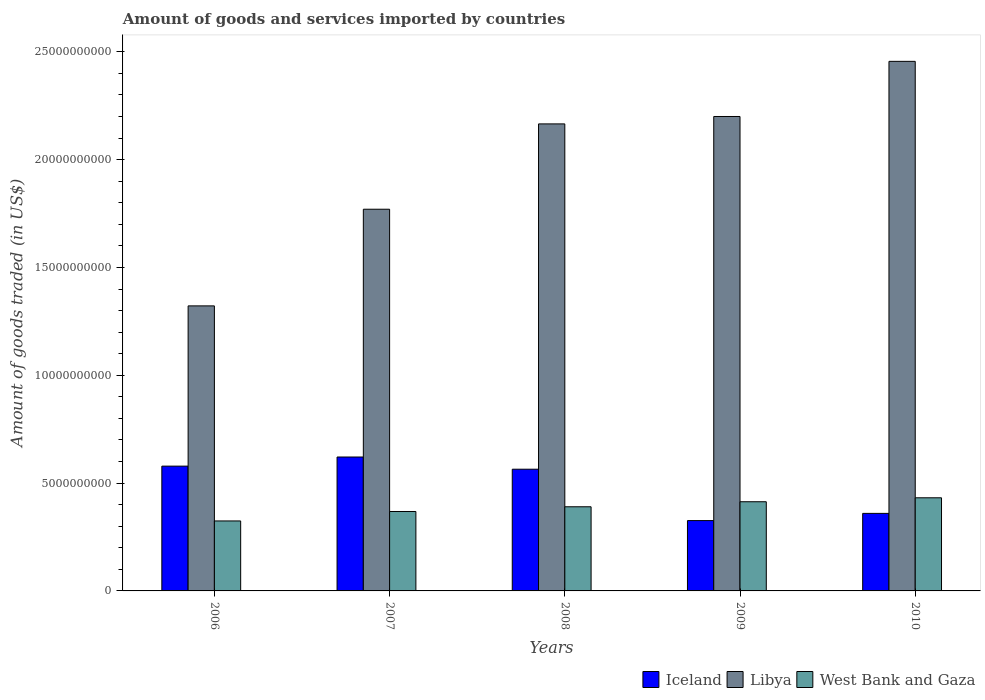How many groups of bars are there?
Offer a terse response. 5. What is the total amount of goods and services imported in Libya in 2006?
Give a very brief answer. 1.32e+1. Across all years, what is the maximum total amount of goods and services imported in Iceland?
Provide a succinct answer. 6.21e+09. Across all years, what is the minimum total amount of goods and services imported in Libya?
Your answer should be compact. 1.32e+1. What is the total total amount of goods and services imported in Libya in the graph?
Offer a very short reply. 9.91e+1. What is the difference between the total amount of goods and services imported in Libya in 2006 and that in 2009?
Ensure brevity in your answer.  -8.78e+09. What is the difference between the total amount of goods and services imported in Iceland in 2007 and the total amount of goods and services imported in Libya in 2006?
Provide a short and direct response. -7.01e+09. What is the average total amount of goods and services imported in West Bank and Gaza per year?
Ensure brevity in your answer.  3.86e+09. In the year 2010, what is the difference between the total amount of goods and services imported in Libya and total amount of goods and services imported in West Bank and Gaza?
Ensure brevity in your answer.  2.02e+1. In how many years, is the total amount of goods and services imported in Iceland greater than 10000000000 US$?
Your answer should be very brief. 0. What is the ratio of the total amount of goods and services imported in West Bank and Gaza in 2006 to that in 2008?
Provide a short and direct response. 0.83. What is the difference between the highest and the second highest total amount of goods and services imported in Libya?
Give a very brief answer. 2.56e+09. What is the difference between the highest and the lowest total amount of goods and services imported in West Bank and Gaza?
Provide a succinct answer. 1.07e+09. What does the 2nd bar from the left in 2006 represents?
Make the answer very short. Libya. What does the 1st bar from the right in 2006 represents?
Provide a succinct answer. West Bank and Gaza. Is it the case that in every year, the sum of the total amount of goods and services imported in Iceland and total amount of goods and services imported in West Bank and Gaza is greater than the total amount of goods and services imported in Libya?
Provide a succinct answer. No. How many bars are there?
Offer a very short reply. 15. Are all the bars in the graph horizontal?
Keep it short and to the point. No. How many years are there in the graph?
Provide a succinct answer. 5. What is the difference between two consecutive major ticks on the Y-axis?
Offer a very short reply. 5.00e+09. Where does the legend appear in the graph?
Your response must be concise. Bottom right. How many legend labels are there?
Your answer should be compact. 3. How are the legend labels stacked?
Provide a short and direct response. Horizontal. What is the title of the graph?
Your response must be concise. Amount of goods and services imported by countries. Does "Lithuania" appear as one of the legend labels in the graph?
Your response must be concise. No. What is the label or title of the Y-axis?
Ensure brevity in your answer.  Amount of goods traded (in US$). What is the Amount of goods traded (in US$) of Iceland in 2006?
Keep it short and to the point. 5.79e+09. What is the Amount of goods traded (in US$) in Libya in 2006?
Give a very brief answer. 1.32e+1. What is the Amount of goods traded (in US$) of West Bank and Gaza in 2006?
Provide a short and direct response. 3.25e+09. What is the Amount of goods traded (in US$) of Iceland in 2007?
Provide a short and direct response. 6.21e+09. What is the Amount of goods traded (in US$) of Libya in 2007?
Provide a succinct answer. 1.77e+1. What is the Amount of goods traded (in US$) in West Bank and Gaza in 2007?
Offer a very short reply. 3.68e+09. What is the Amount of goods traded (in US$) in Iceland in 2008?
Your answer should be compact. 5.64e+09. What is the Amount of goods traded (in US$) in Libya in 2008?
Provide a succinct answer. 2.17e+1. What is the Amount of goods traded (in US$) in West Bank and Gaza in 2008?
Keep it short and to the point. 3.90e+09. What is the Amount of goods traded (in US$) of Iceland in 2009?
Offer a terse response. 3.26e+09. What is the Amount of goods traded (in US$) of Libya in 2009?
Keep it short and to the point. 2.20e+1. What is the Amount of goods traded (in US$) in West Bank and Gaza in 2009?
Your response must be concise. 4.14e+09. What is the Amount of goods traded (in US$) in Iceland in 2010?
Make the answer very short. 3.60e+09. What is the Amount of goods traded (in US$) in Libya in 2010?
Ensure brevity in your answer.  2.46e+1. What is the Amount of goods traded (in US$) of West Bank and Gaza in 2010?
Offer a very short reply. 4.32e+09. Across all years, what is the maximum Amount of goods traded (in US$) in Iceland?
Keep it short and to the point. 6.21e+09. Across all years, what is the maximum Amount of goods traded (in US$) of Libya?
Make the answer very short. 2.46e+1. Across all years, what is the maximum Amount of goods traded (in US$) in West Bank and Gaza?
Keep it short and to the point. 4.32e+09. Across all years, what is the minimum Amount of goods traded (in US$) of Iceland?
Give a very brief answer. 3.26e+09. Across all years, what is the minimum Amount of goods traded (in US$) in Libya?
Offer a very short reply. 1.32e+1. Across all years, what is the minimum Amount of goods traded (in US$) of West Bank and Gaza?
Your response must be concise. 3.25e+09. What is the total Amount of goods traded (in US$) in Iceland in the graph?
Provide a succinct answer. 2.45e+1. What is the total Amount of goods traded (in US$) in Libya in the graph?
Keep it short and to the point. 9.91e+1. What is the total Amount of goods traded (in US$) of West Bank and Gaza in the graph?
Your answer should be compact. 1.93e+1. What is the difference between the Amount of goods traded (in US$) in Iceland in 2006 and that in 2007?
Ensure brevity in your answer.  -4.23e+08. What is the difference between the Amount of goods traded (in US$) of Libya in 2006 and that in 2007?
Ensure brevity in your answer.  -4.48e+09. What is the difference between the Amount of goods traded (in US$) in West Bank and Gaza in 2006 and that in 2007?
Offer a very short reply. -4.38e+08. What is the difference between the Amount of goods traded (in US$) in Iceland in 2006 and that in 2008?
Offer a terse response. 1.43e+08. What is the difference between the Amount of goods traded (in US$) of Libya in 2006 and that in 2008?
Give a very brief answer. -8.44e+09. What is the difference between the Amount of goods traded (in US$) of West Bank and Gaza in 2006 and that in 2008?
Provide a short and direct response. -6.58e+08. What is the difference between the Amount of goods traded (in US$) in Iceland in 2006 and that in 2009?
Provide a short and direct response. 2.53e+09. What is the difference between the Amount of goods traded (in US$) in Libya in 2006 and that in 2009?
Your answer should be compact. -8.78e+09. What is the difference between the Amount of goods traded (in US$) of West Bank and Gaza in 2006 and that in 2009?
Give a very brief answer. -8.91e+08. What is the difference between the Amount of goods traded (in US$) of Iceland in 2006 and that in 2010?
Ensure brevity in your answer.  2.19e+09. What is the difference between the Amount of goods traded (in US$) in Libya in 2006 and that in 2010?
Provide a succinct answer. -1.13e+1. What is the difference between the Amount of goods traded (in US$) in West Bank and Gaza in 2006 and that in 2010?
Your answer should be very brief. -1.07e+09. What is the difference between the Amount of goods traded (in US$) of Iceland in 2007 and that in 2008?
Ensure brevity in your answer.  5.66e+08. What is the difference between the Amount of goods traded (in US$) of Libya in 2007 and that in 2008?
Make the answer very short. -3.96e+09. What is the difference between the Amount of goods traded (in US$) in West Bank and Gaza in 2007 and that in 2008?
Provide a short and direct response. -2.19e+08. What is the difference between the Amount of goods traded (in US$) of Iceland in 2007 and that in 2009?
Provide a short and direct response. 2.95e+09. What is the difference between the Amount of goods traded (in US$) in Libya in 2007 and that in 2009?
Your response must be concise. -4.30e+09. What is the difference between the Amount of goods traded (in US$) in West Bank and Gaza in 2007 and that in 2009?
Give a very brief answer. -4.52e+08. What is the difference between the Amount of goods traded (in US$) in Iceland in 2007 and that in 2010?
Your answer should be compact. 2.61e+09. What is the difference between the Amount of goods traded (in US$) in Libya in 2007 and that in 2010?
Your response must be concise. -6.86e+09. What is the difference between the Amount of goods traded (in US$) in West Bank and Gaza in 2007 and that in 2010?
Your answer should be very brief. -6.35e+08. What is the difference between the Amount of goods traded (in US$) in Iceland in 2008 and that in 2009?
Give a very brief answer. 2.38e+09. What is the difference between the Amount of goods traded (in US$) of Libya in 2008 and that in 2009?
Offer a terse response. -3.44e+08. What is the difference between the Amount of goods traded (in US$) of West Bank and Gaza in 2008 and that in 2009?
Your answer should be very brief. -2.33e+08. What is the difference between the Amount of goods traded (in US$) in Iceland in 2008 and that in 2010?
Give a very brief answer. 2.05e+09. What is the difference between the Amount of goods traded (in US$) of Libya in 2008 and that in 2010?
Offer a very short reply. -2.90e+09. What is the difference between the Amount of goods traded (in US$) of West Bank and Gaza in 2008 and that in 2010?
Your response must be concise. -4.16e+08. What is the difference between the Amount of goods traded (in US$) in Iceland in 2009 and that in 2010?
Keep it short and to the point. -3.34e+08. What is the difference between the Amount of goods traded (in US$) in Libya in 2009 and that in 2010?
Provide a short and direct response. -2.56e+09. What is the difference between the Amount of goods traded (in US$) in West Bank and Gaza in 2009 and that in 2010?
Keep it short and to the point. -1.83e+08. What is the difference between the Amount of goods traded (in US$) in Iceland in 2006 and the Amount of goods traded (in US$) in Libya in 2007?
Give a very brief answer. -1.19e+1. What is the difference between the Amount of goods traded (in US$) of Iceland in 2006 and the Amount of goods traded (in US$) of West Bank and Gaza in 2007?
Make the answer very short. 2.10e+09. What is the difference between the Amount of goods traded (in US$) in Libya in 2006 and the Amount of goods traded (in US$) in West Bank and Gaza in 2007?
Offer a very short reply. 9.54e+09. What is the difference between the Amount of goods traded (in US$) in Iceland in 2006 and the Amount of goods traded (in US$) in Libya in 2008?
Offer a very short reply. -1.59e+1. What is the difference between the Amount of goods traded (in US$) of Iceland in 2006 and the Amount of goods traded (in US$) of West Bank and Gaza in 2008?
Make the answer very short. 1.88e+09. What is the difference between the Amount of goods traded (in US$) in Libya in 2006 and the Amount of goods traded (in US$) in West Bank and Gaza in 2008?
Ensure brevity in your answer.  9.32e+09. What is the difference between the Amount of goods traded (in US$) of Iceland in 2006 and the Amount of goods traded (in US$) of Libya in 2009?
Your response must be concise. -1.62e+1. What is the difference between the Amount of goods traded (in US$) of Iceland in 2006 and the Amount of goods traded (in US$) of West Bank and Gaza in 2009?
Your answer should be compact. 1.65e+09. What is the difference between the Amount of goods traded (in US$) of Libya in 2006 and the Amount of goods traded (in US$) of West Bank and Gaza in 2009?
Provide a short and direct response. 9.08e+09. What is the difference between the Amount of goods traded (in US$) in Iceland in 2006 and the Amount of goods traded (in US$) in Libya in 2010?
Offer a very short reply. -1.88e+1. What is the difference between the Amount of goods traded (in US$) of Iceland in 2006 and the Amount of goods traded (in US$) of West Bank and Gaza in 2010?
Give a very brief answer. 1.47e+09. What is the difference between the Amount of goods traded (in US$) in Libya in 2006 and the Amount of goods traded (in US$) in West Bank and Gaza in 2010?
Your answer should be compact. 8.90e+09. What is the difference between the Amount of goods traded (in US$) of Iceland in 2007 and the Amount of goods traded (in US$) of Libya in 2008?
Make the answer very short. -1.54e+1. What is the difference between the Amount of goods traded (in US$) in Iceland in 2007 and the Amount of goods traded (in US$) in West Bank and Gaza in 2008?
Give a very brief answer. 2.31e+09. What is the difference between the Amount of goods traded (in US$) in Libya in 2007 and the Amount of goods traded (in US$) in West Bank and Gaza in 2008?
Offer a terse response. 1.38e+1. What is the difference between the Amount of goods traded (in US$) of Iceland in 2007 and the Amount of goods traded (in US$) of Libya in 2009?
Provide a short and direct response. -1.58e+1. What is the difference between the Amount of goods traded (in US$) of Iceland in 2007 and the Amount of goods traded (in US$) of West Bank and Gaza in 2009?
Your answer should be very brief. 2.07e+09. What is the difference between the Amount of goods traded (in US$) of Libya in 2007 and the Amount of goods traded (in US$) of West Bank and Gaza in 2009?
Provide a succinct answer. 1.36e+1. What is the difference between the Amount of goods traded (in US$) in Iceland in 2007 and the Amount of goods traded (in US$) in Libya in 2010?
Offer a very short reply. -1.83e+1. What is the difference between the Amount of goods traded (in US$) of Iceland in 2007 and the Amount of goods traded (in US$) of West Bank and Gaza in 2010?
Keep it short and to the point. 1.89e+09. What is the difference between the Amount of goods traded (in US$) of Libya in 2007 and the Amount of goods traded (in US$) of West Bank and Gaza in 2010?
Your response must be concise. 1.34e+1. What is the difference between the Amount of goods traded (in US$) in Iceland in 2008 and the Amount of goods traded (in US$) in Libya in 2009?
Provide a succinct answer. -1.64e+1. What is the difference between the Amount of goods traded (in US$) of Iceland in 2008 and the Amount of goods traded (in US$) of West Bank and Gaza in 2009?
Give a very brief answer. 1.51e+09. What is the difference between the Amount of goods traded (in US$) of Libya in 2008 and the Amount of goods traded (in US$) of West Bank and Gaza in 2009?
Keep it short and to the point. 1.75e+1. What is the difference between the Amount of goods traded (in US$) of Iceland in 2008 and the Amount of goods traded (in US$) of Libya in 2010?
Provide a succinct answer. -1.89e+1. What is the difference between the Amount of goods traded (in US$) in Iceland in 2008 and the Amount of goods traded (in US$) in West Bank and Gaza in 2010?
Your response must be concise. 1.33e+09. What is the difference between the Amount of goods traded (in US$) in Libya in 2008 and the Amount of goods traded (in US$) in West Bank and Gaza in 2010?
Make the answer very short. 1.73e+1. What is the difference between the Amount of goods traded (in US$) of Iceland in 2009 and the Amount of goods traded (in US$) of Libya in 2010?
Give a very brief answer. -2.13e+1. What is the difference between the Amount of goods traded (in US$) in Iceland in 2009 and the Amount of goods traded (in US$) in West Bank and Gaza in 2010?
Provide a succinct answer. -1.06e+09. What is the difference between the Amount of goods traded (in US$) of Libya in 2009 and the Amount of goods traded (in US$) of West Bank and Gaza in 2010?
Keep it short and to the point. 1.77e+1. What is the average Amount of goods traded (in US$) in Iceland per year?
Give a very brief answer. 4.90e+09. What is the average Amount of goods traded (in US$) of Libya per year?
Your response must be concise. 1.98e+1. What is the average Amount of goods traded (in US$) of West Bank and Gaza per year?
Your answer should be compact. 3.86e+09. In the year 2006, what is the difference between the Amount of goods traded (in US$) in Iceland and Amount of goods traded (in US$) in Libya?
Offer a terse response. -7.43e+09. In the year 2006, what is the difference between the Amount of goods traded (in US$) in Iceland and Amount of goods traded (in US$) in West Bank and Gaza?
Ensure brevity in your answer.  2.54e+09. In the year 2006, what is the difference between the Amount of goods traded (in US$) in Libya and Amount of goods traded (in US$) in West Bank and Gaza?
Provide a short and direct response. 9.97e+09. In the year 2007, what is the difference between the Amount of goods traded (in US$) of Iceland and Amount of goods traded (in US$) of Libya?
Provide a succinct answer. -1.15e+1. In the year 2007, what is the difference between the Amount of goods traded (in US$) of Iceland and Amount of goods traded (in US$) of West Bank and Gaza?
Offer a very short reply. 2.53e+09. In the year 2007, what is the difference between the Amount of goods traded (in US$) of Libya and Amount of goods traded (in US$) of West Bank and Gaza?
Give a very brief answer. 1.40e+1. In the year 2008, what is the difference between the Amount of goods traded (in US$) of Iceland and Amount of goods traded (in US$) of Libya?
Keep it short and to the point. -1.60e+1. In the year 2008, what is the difference between the Amount of goods traded (in US$) in Iceland and Amount of goods traded (in US$) in West Bank and Gaza?
Keep it short and to the point. 1.74e+09. In the year 2008, what is the difference between the Amount of goods traded (in US$) in Libya and Amount of goods traded (in US$) in West Bank and Gaza?
Your answer should be very brief. 1.78e+1. In the year 2009, what is the difference between the Amount of goods traded (in US$) of Iceland and Amount of goods traded (in US$) of Libya?
Your answer should be compact. -1.87e+1. In the year 2009, what is the difference between the Amount of goods traded (in US$) of Iceland and Amount of goods traded (in US$) of West Bank and Gaza?
Offer a very short reply. -8.74e+08. In the year 2009, what is the difference between the Amount of goods traded (in US$) of Libya and Amount of goods traded (in US$) of West Bank and Gaza?
Your response must be concise. 1.79e+1. In the year 2010, what is the difference between the Amount of goods traded (in US$) of Iceland and Amount of goods traded (in US$) of Libya?
Ensure brevity in your answer.  -2.10e+1. In the year 2010, what is the difference between the Amount of goods traded (in US$) of Iceland and Amount of goods traded (in US$) of West Bank and Gaza?
Keep it short and to the point. -7.23e+08. In the year 2010, what is the difference between the Amount of goods traded (in US$) of Libya and Amount of goods traded (in US$) of West Bank and Gaza?
Your response must be concise. 2.02e+1. What is the ratio of the Amount of goods traded (in US$) of Iceland in 2006 to that in 2007?
Keep it short and to the point. 0.93. What is the ratio of the Amount of goods traded (in US$) in Libya in 2006 to that in 2007?
Offer a terse response. 0.75. What is the ratio of the Amount of goods traded (in US$) of West Bank and Gaza in 2006 to that in 2007?
Your answer should be very brief. 0.88. What is the ratio of the Amount of goods traded (in US$) of Iceland in 2006 to that in 2008?
Provide a succinct answer. 1.03. What is the ratio of the Amount of goods traded (in US$) of Libya in 2006 to that in 2008?
Provide a succinct answer. 0.61. What is the ratio of the Amount of goods traded (in US$) of West Bank and Gaza in 2006 to that in 2008?
Provide a short and direct response. 0.83. What is the ratio of the Amount of goods traded (in US$) in Iceland in 2006 to that in 2009?
Your response must be concise. 1.77. What is the ratio of the Amount of goods traded (in US$) in Libya in 2006 to that in 2009?
Keep it short and to the point. 0.6. What is the ratio of the Amount of goods traded (in US$) of West Bank and Gaza in 2006 to that in 2009?
Your response must be concise. 0.78. What is the ratio of the Amount of goods traded (in US$) in Iceland in 2006 to that in 2010?
Offer a terse response. 1.61. What is the ratio of the Amount of goods traded (in US$) of Libya in 2006 to that in 2010?
Offer a very short reply. 0.54. What is the ratio of the Amount of goods traded (in US$) in West Bank and Gaza in 2006 to that in 2010?
Ensure brevity in your answer.  0.75. What is the ratio of the Amount of goods traded (in US$) of Iceland in 2007 to that in 2008?
Offer a terse response. 1.1. What is the ratio of the Amount of goods traded (in US$) in Libya in 2007 to that in 2008?
Your answer should be very brief. 0.82. What is the ratio of the Amount of goods traded (in US$) of West Bank and Gaza in 2007 to that in 2008?
Ensure brevity in your answer.  0.94. What is the ratio of the Amount of goods traded (in US$) in Iceland in 2007 to that in 2009?
Provide a short and direct response. 1.9. What is the ratio of the Amount of goods traded (in US$) in Libya in 2007 to that in 2009?
Your answer should be compact. 0.8. What is the ratio of the Amount of goods traded (in US$) in West Bank and Gaza in 2007 to that in 2009?
Provide a short and direct response. 0.89. What is the ratio of the Amount of goods traded (in US$) in Iceland in 2007 to that in 2010?
Provide a short and direct response. 1.73. What is the ratio of the Amount of goods traded (in US$) in Libya in 2007 to that in 2010?
Give a very brief answer. 0.72. What is the ratio of the Amount of goods traded (in US$) of West Bank and Gaza in 2007 to that in 2010?
Your answer should be very brief. 0.85. What is the ratio of the Amount of goods traded (in US$) in Iceland in 2008 to that in 2009?
Ensure brevity in your answer.  1.73. What is the ratio of the Amount of goods traded (in US$) of Libya in 2008 to that in 2009?
Keep it short and to the point. 0.98. What is the ratio of the Amount of goods traded (in US$) in West Bank and Gaza in 2008 to that in 2009?
Offer a terse response. 0.94. What is the ratio of the Amount of goods traded (in US$) of Iceland in 2008 to that in 2010?
Keep it short and to the point. 1.57. What is the ratio of the Amount of goods traded (in US$) in Libya in 2008 to that in 2010?
Your response must be concise. 0.88. What is the ratio of the Amount of goods traded (in US$) of West Bank and Gaza in 2008 to that in 2010?
Your answer should be very brief. 0.9. What is the ratio of the Amount of goods traded (in US$) in Iceland in 2009 to that in 2010?
Keep it short and to the point. 0.91. What is the ratio of the Amount of goods traded (in US$) in Libya in 2009 to that in 2010?
Give a very brief answer. 0.9. What is the ratio of the Amount of goods traded (in US$) of West Bank and Gaza in 2009 to that in 2010?
Your response must be concise. 0.96. What is the difference between the highest and the second highest Amount of goods traded (in US$) in Iceland?
Your answer should be compact. 4.23e+08. What is the difference between the highest and the second highest Amount of goods traded (in US$) of Libya?
Give a very brief answer. 2.56e+09. What is the difference between the highest and the second highest Amount of goods traded (in US$) of West Bank and Gaza?
Give a very brief answer. 1.83e+08. What is the difference between the highest and the lowest Amount of goods traded (in US$) of Iceland?
Provide a short and direct response. 2.95e+09. What is the difference between the highest and the lowest Amount of goods traded (in US$) of Libya?
Offer a terse response. 1.13e+1. What is the difference between the highest and the lowest Amount of goods traded (in US$) in West Bank and Gaza?
Give a very brief answer. 1.07e+09. 